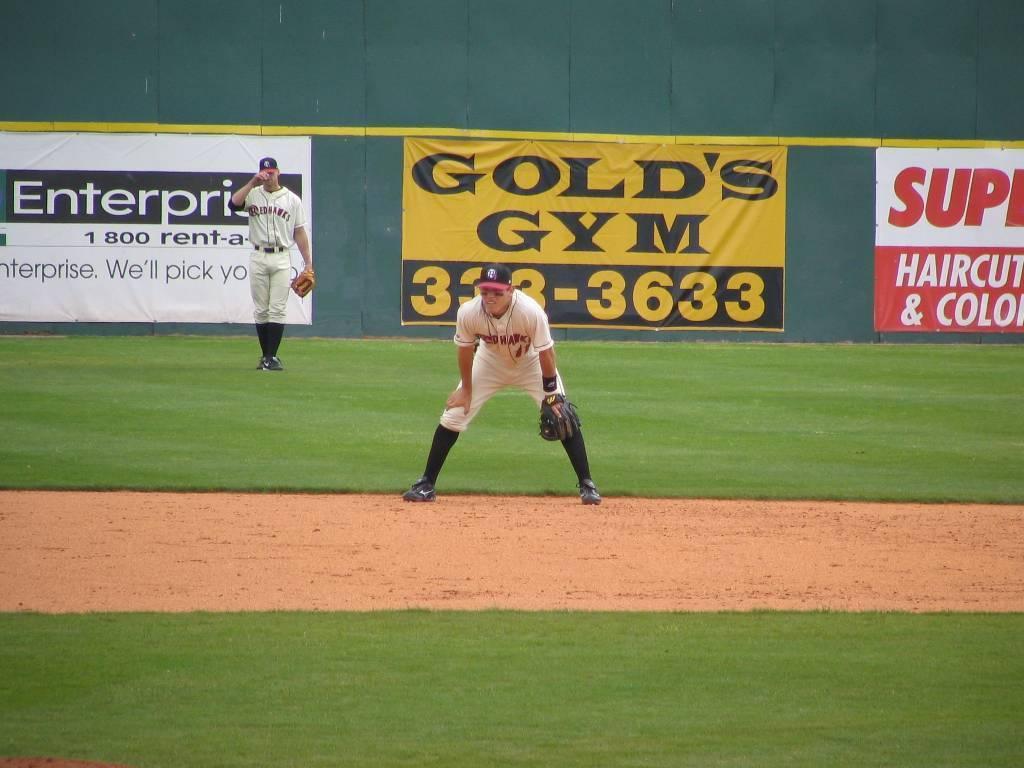What is the phone number to gold's gym?
Ensure brevity in your answer.  333-3633. What kind of business is gold's?
Provide a succinct answer. Gym. 